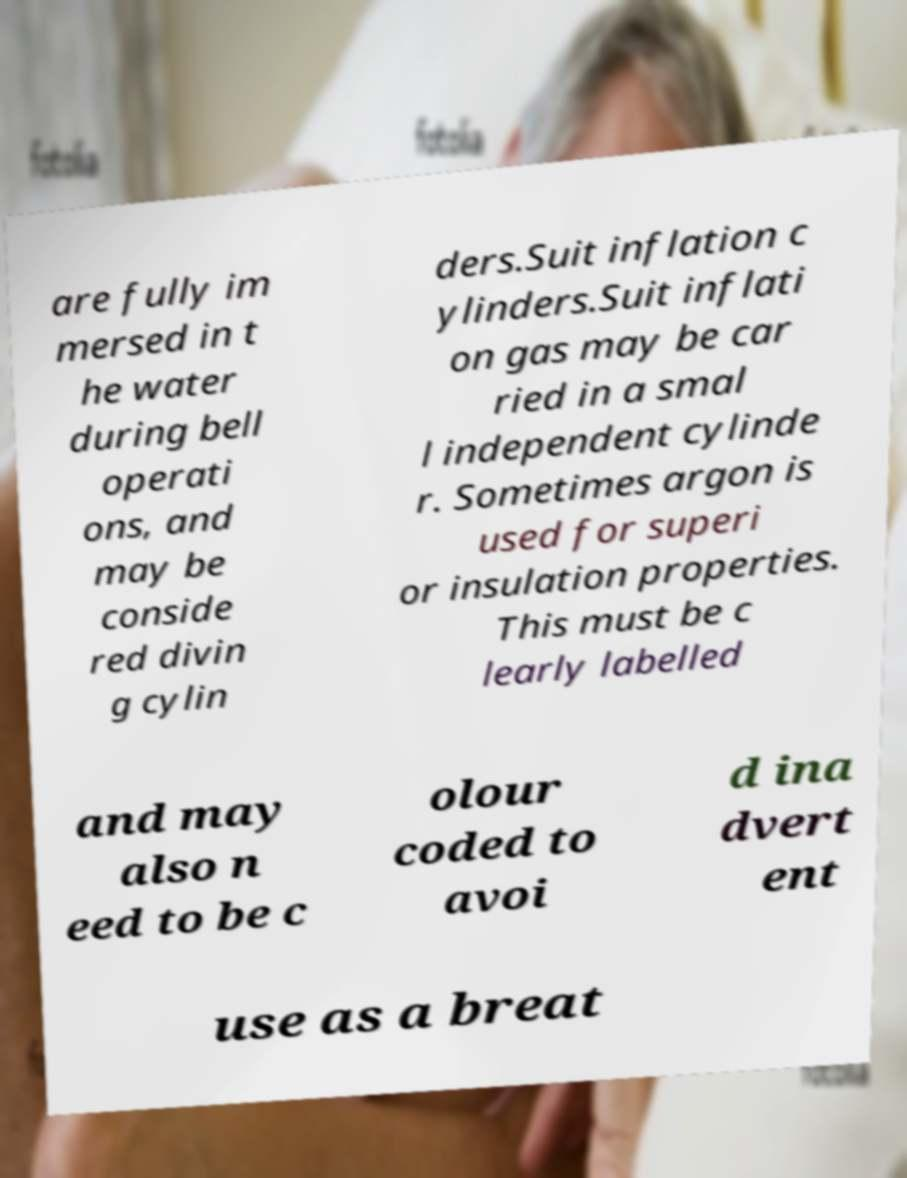What messages or text are displayed in this image? I need them in a readable, typed format. are fully im mersed in t he water during bell operati ons, and may be conside red divin g cylin ders.Suit inflation c ylinders.Suit inflati on gas may be car ried in a smal l independent cylinde r. Sometimes argon is used for superi or insulation properties. This must be c learly labelled and may also n eed to be c olour coded to avoi d ina dvert ent use as a breat 